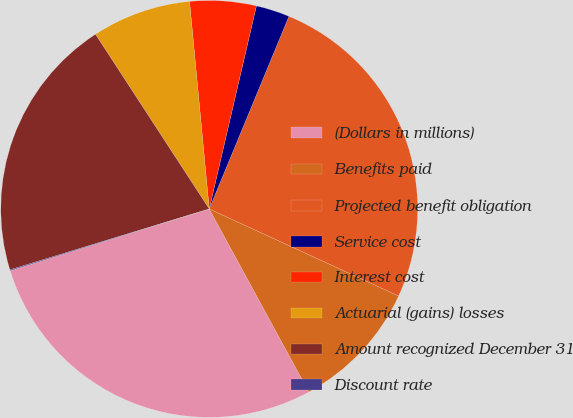Convert chart to OTSL. <chart><loc_0><loc_0><loc_500><loc_500><pie_chart><fcel>(Dollars in millions)<fcel>Benefits paid<fcel>Projected benefit obligation<fcel>Service cost<fcel>Interest cost<fcel>Actuarial (gains) losses<fcel>Amount recognized December 31<fcel>Discount rate<nl><fcel>28.14%<fcel>10.21%<fcel>25.61%<fcel>2.61%<fcel>5.14%<fcel>7.68%<fcel>20.53%<fcel>0.07%<nl></chart> 